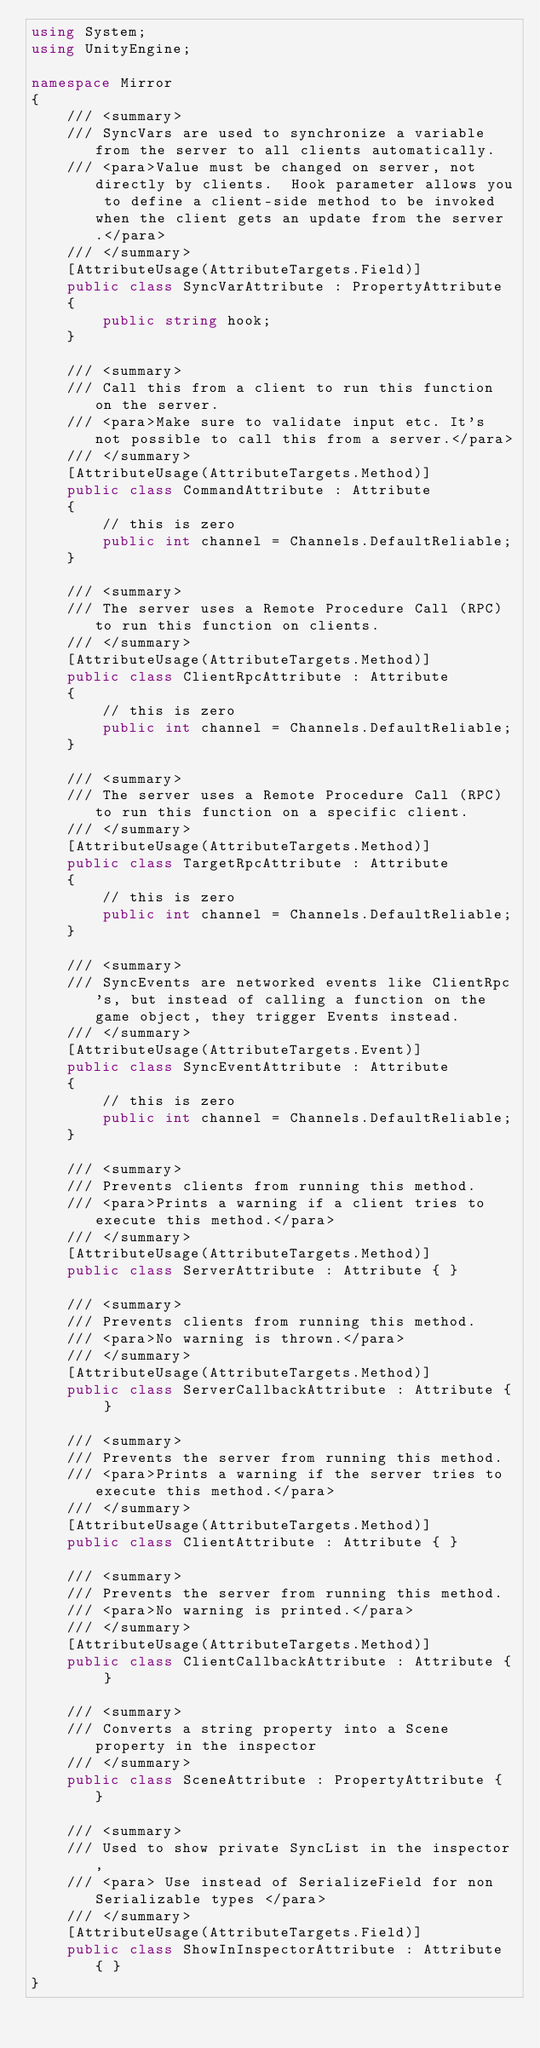Convert code to text. <code><loc_0><loc_0><loc_500><loc_500><_C#_>using System;
using UnityEngine;

namespace Mirror
{
    /// <summary>
    /// SyncVars are used to synchronize a variable from the server to all clients automatically.
    /// <para>Value must be changed on server, not directly by clients.  Hook parameter allows you to define a client-side method to be invoked when the client gets an update from the server.</para>
    /// </summary>
    [AttributeUsage(AttributeTargets.Field)]
    public class SyncVarAttribute : PropertyAttribute
    {
        public string hook;
    }

    /// <summary>
    /// Call this from a client to run this function on the server.
    /// <para>Make sure to validate input etc. It's not possible to call this from a server.</para>
    /// </summary>
    [AttributeUsage(AttributeTargets.Method)]
    public class CommandAttribute : Attribute
    {
        // this is zero
        public int channel = Channels.DefaultReliable;
    }

    /// <summary>
    /// The server uses a Remote Procedure Call (RPC) to run this function on clients.
    /// </summary>
    [AttributeUsage(AttributeTargets.Method)]
    public class ClientRpcAttribute : Attribute
    {
        // this is zero
        public int channel = Channels.DefaultReliable;
    }

    /// <summary>
    /// The server uses a Remote Procedure Call (RPC) to run this function on a specific client.
    /// </summary>
    [AttributeUsage(AttributeTargets.Method)]
    public class TargetRpcAttribute : Attribute
    {
        // this is zero
        public int channel = Channels.DefaultReliable;
    }

    /// <summary>
    /// SyncEvents are networked events like ClientRpc's, but instead of calling a function on the game object, they trigger Events instead.
    /// </summary>
    [AttributeUsage(AttributeTargets.Event)]
    public class SyncEventAttribute : Attribute
    {
        // this is zero
        public int channel = Channels.DefaultReliable;
    }

    /// <summary>
    /// Prevents clients from running this method.
    /// <para>Prints a warning if a client tries to execute this method.</para>
    /// </summary>
    [AttributeUsage(AttributeTargets.Method)]
    public class ServerAttribute : Attribute { }

    /// <summary>
    /// Prevents clients from running this method.
    /// <para>No warning is thrown.</para>
    /// </summary>
    [AttributeUsage(AttributeTargets.Method)]
    public class ServerCallbackAttribute : Attribute { }

    /// <summary>
    /// Prevents the server from running this method.
    /// <para>Prints a warning if the server tries to execute this method.</para>
    /// </summary>
    [AttributeUsage(AttributeTargets.Method)]
    public class ClientAttribute : Attribute { }

    /// <summary>
    /// Prevents the server from running this method.
    /// <para>No warning is printed.</para>
    /// </summary>
    [AttributeUsage(AttributeTargets.Method)]
    public class ClientCallbackAttribute : Attribute { }

    /// <summary>
    /// Converts a string property into a Scene property in the inspector
    /// </summary>
    public class SceneAttribute : PropertyAttribute { }

    /// <summary>
    /// Used to show private SyncList in the inspector,
    /// <para> Use instead of SerializeField for non Serializable types </para>
    /// </summary>
    [AttributeUsage(AttributeTargets.Field)]
    public class ShowInInspectorAttribute : Attribute { }
}
</code> 